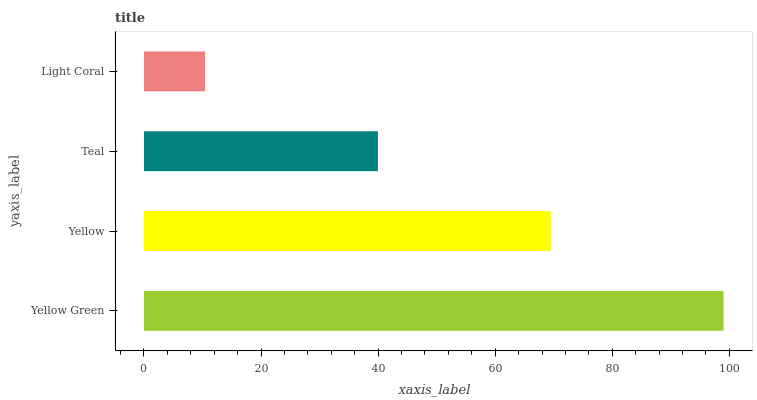Is Light Coral the minimum?
Answer yes or no. Yes. Is Yellow Green the maximum?
Answer yes or no. Yes. Is Yellow the minimum?
Answer yes or no. No. Is Yellow the maximum?
Answer yes or no. No. Is Yellow Green greater than Yellow?
Answer yes or no. Yes. Is Yellow less than Yellow Green?
Answer yes or no. Yes. Is Yellow greater than Yellow Green?
Answer yes or no. No. Is Yellow Green less than Yellow?
Answer yes or no. No. Is Yellow the high median?
Answer yes or no. Yes. Is Teal the low median?
Answer yes or no. Yes. Is Yellow Green the high median?
Answer yes or no. No. Is Yellow the low median?
Answer yes or no. No. 